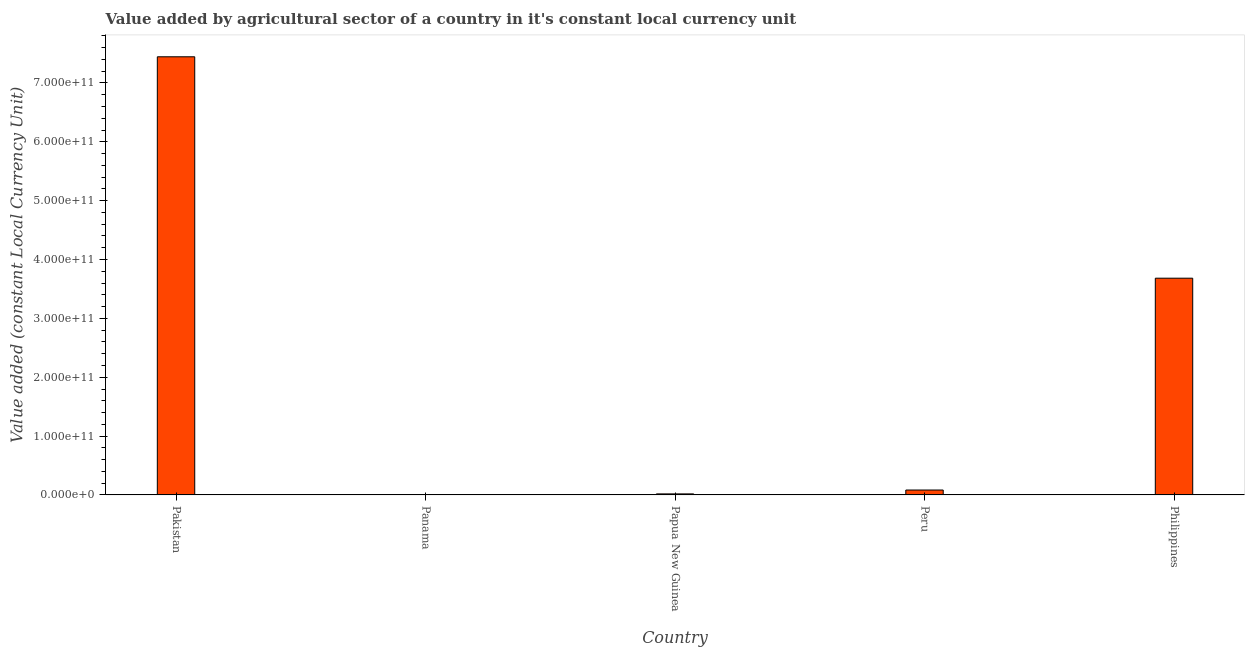Does the graph contain any zero values?
Offer a very short reply. No. What is the title of the graph?
Keep it short and to the point. Value added by agricultural sector of a country in it's constant local currency unit. What is the label or title of the X-axis?
Your answer should be very brief. Country. What is the label or title of the Y-axis?
Ensure brevity in your answer.  Value added (constant Local Currency Unit). What is the value added by agriculture sector in Peru?
Provide a short and direct response. 8.34e+09. Across all countries, what is the maximum value added by agriculture sector?
Offer a very short reply. 7.45e+11. Across all countries, what is the minimum value added by agriculture sector?
Offer a terse response. 5.31e+08. In which country was the value added by agriculture sector maximum?
Offer a terse response. Pakistan. In which country was the value added by agriculture sector minimum?
Ensure brevity in your answer.  Panama. What is the sum of the value added by agriculture sector?
Your answer should be very brief. 1.12e+12. What is the difference between the value added by agriculture sector in Panama and Papua New Guinea?
Keep it short and to the point. -1.24e+09. What is the average value added by agriculture sector per country?
Make the answer very short. 2.25e+11. What is the median value added by agriculture sector?
Keep it short and to the point. 8.34e+09. What is the ratio of the value added by agriculture sector in Pakistan to that in Panama?
Ensure brevity in your answer.  1401.11. What is the difference between the highest and the second highest value added by agriculture sector?
Ensure brevity in your answer.  3.76e+11. Is the sum of the value added by agriculture sector in Panama and Peru greater than the maximum value added by agriculture sector across all countries?
Give a very brief answer. No. What is the difference between the highest and the lowest value added by agriculture sector?
Provide a short and direct response. 7.44e+11. In how many countries, is the value added by agriculture sector greater than the average value added by agriculture sector taken over all countries?
Your response must be concise. 2. Are all the bars in the graph horizontal?
Give a very brief answer. No. What is the difference between two consecutive major ticks on the Y-axis?
Offer a very short reply. 1.00e+11. Are the values on the major ticks of Y-axis written in scientific E-notation?
Give a very brief answer. Yes. What is the Value added (constant Local Currency Unit) in Pakistan?
Ensure brevity in your answer.  7.45e+11. What is the Value added (constant Local Currency Unit) of Panama?
Ensure brevity in your answer.  5.31e+08. What is the Value added (constant Local Currency Unit) in Papua New Guinea?
Ensure brevity in your answer.  1.77e+09. What is the Value added (constant Local Currency Unit) of Peru?
Provide a succinct answer. 8.34e+09. What is the Value added (constant Local Currency Unit) in Philippines?
Offer a terse response. 3.68e+11. What is the difference between the Value added (constant Local Currency Unit) in Pakistan and Panama?
Your answer should be very brief. 7.44e+11. What is the difference between the Value added (constant Local Currency Unit) in Pakistan and Papua New Guinea?
Provide a short and direct response. 7.43e+11. What is the difference between the Value added (constant Local Currency Unit) in Pakistan and Peru?
Make the answer very short. 7.36e+11. What is the difference between the Value added (constant Local Currency Unit) in Pakistan and Philippines?
Provide a short and direct response. 3.76e+11. What is the difference between the Value added (constant Local Currency Unit) in Panama and Papua New Guinea?
Make the answer very short. -1.24e+09. What is the difference between the Value added (constant Local Currency Unit) in Panama and Peru?
Your answer should be very brief. -7.81e+09. What is the difference between the Value added (constant Local Currency Unit) in Panama and Philippines?
Your answer should be compact. -3.68e+11. What is the difference between the Value added (constant Local Currency Unit) in Papua New Guinea and Peru?
Your answer should be very brief. -6.58e+09. What is the difference between the Value added (constant Local Currency Unit) in Papua New Guinea and Philippines?
Offer a very short reply. -3.67e+11. What is the difference between the Value added (constant Local Currency Unit) in Peru and Philippines?
Offer a terse response. -3.60e+11. What is the ratio of the Value added (constant Local Currency Unit) in Pakistan to that in Panama?
Give a very brief answer. 1401.11. What is the ratio of the Value added (constant Local Currency Unit) in Pakistan to that in Papua New Guinea?
Ensure brevity in your answer.  421.46. What is the ratio of the Value added (constant Local Currency Unit) in Pakistan to that in Peru?
Provide a succinct answer. 89.22. What is the ratio of the Value added (constant Local Currency Unit) in Pakistan to that in Philippines?
Your response must be concise. 2.02. What is the ratio of the Value added (constant Local Currency Unit) in Panama to that in Papua New Guinea?
Provide a succinct answer. 0.3. What is the ratio of the Value added (constant Local Currency Unit) in Panama to that in Peru?
Offer a very short reply. 0.06. What is the ratio of the Value added (constant Local Currency Unit) in Panama to that in Philippines?
Ensure brevity in your answer.  0. What is the ratio of the Value added (constant Local Currency Unit) in Papua New Guinea to that in Peru?
Offer a very short reply. 0.21. What is the ratio of the Value added (constant Local Currency Unit) in Papua New Guinea to that in Philippines?
Provide a succinct answer. 0.01. What is the ratio of the Value added (constant Local Currency Unit) in Peru to that in Philippines?
Provide a short and direct response. 0.02. 